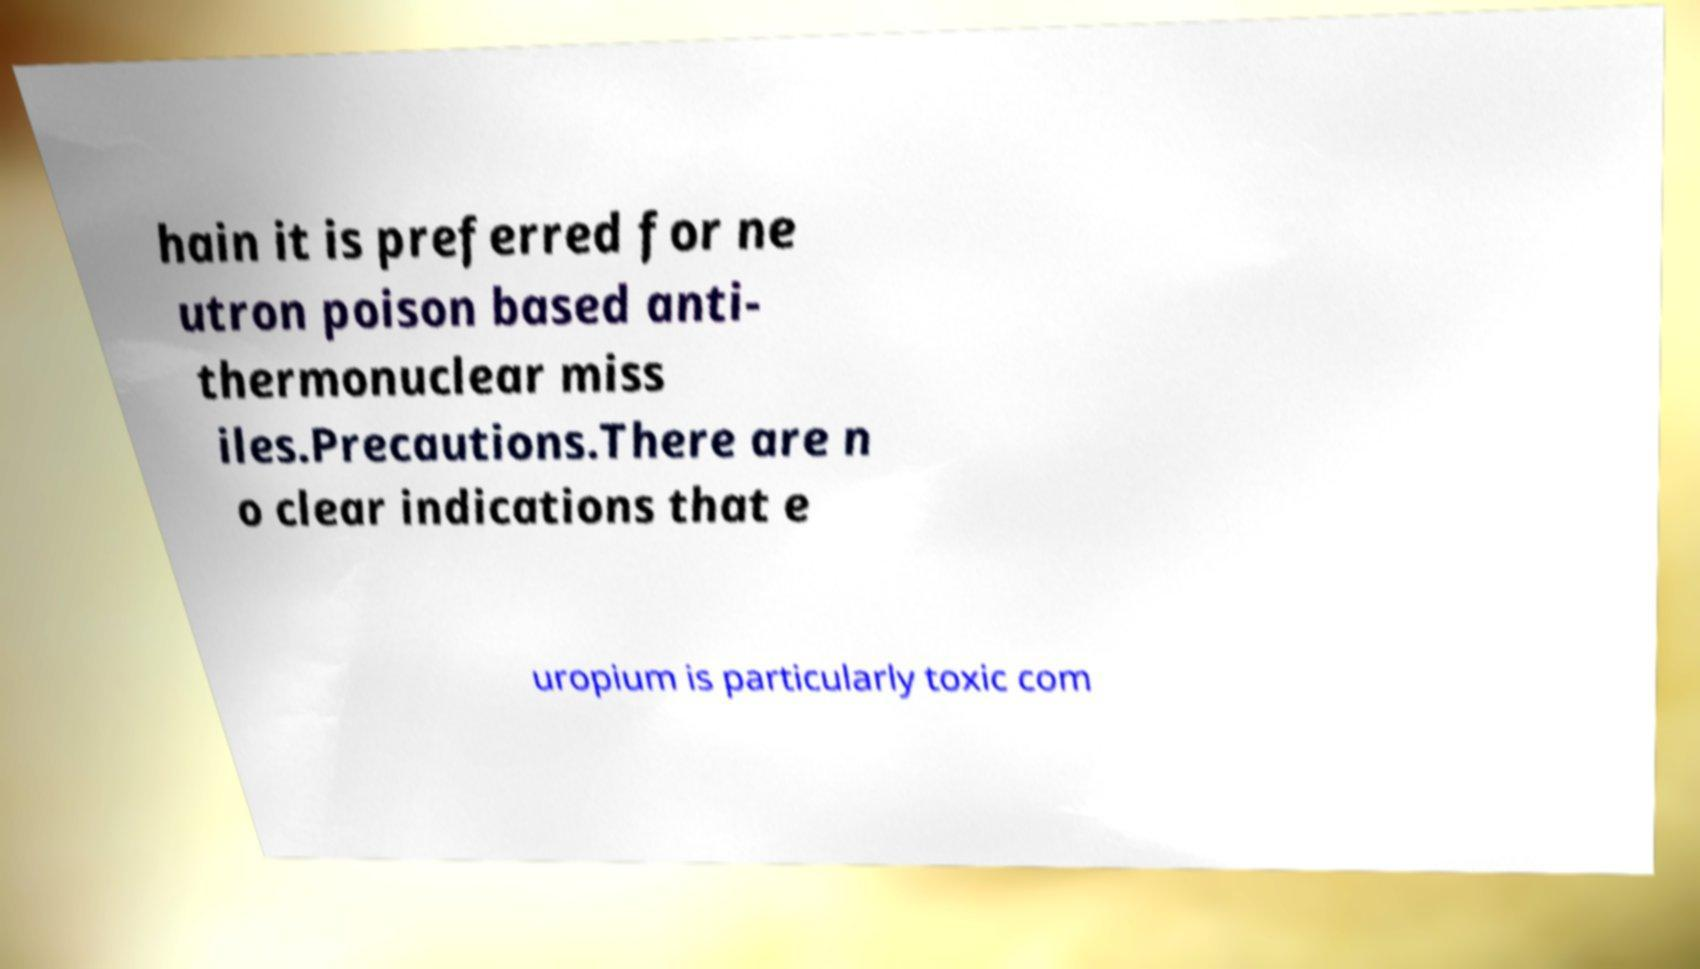Can you read and provide the text displayed in the image?This photo seems to have some interesting text. Can you extract and type it out for me? hain it is preferred for ne utron poison based anti- thermonuclear miss iles.Precautions.There are n o clear indications that e uropium is particularly toxic com 